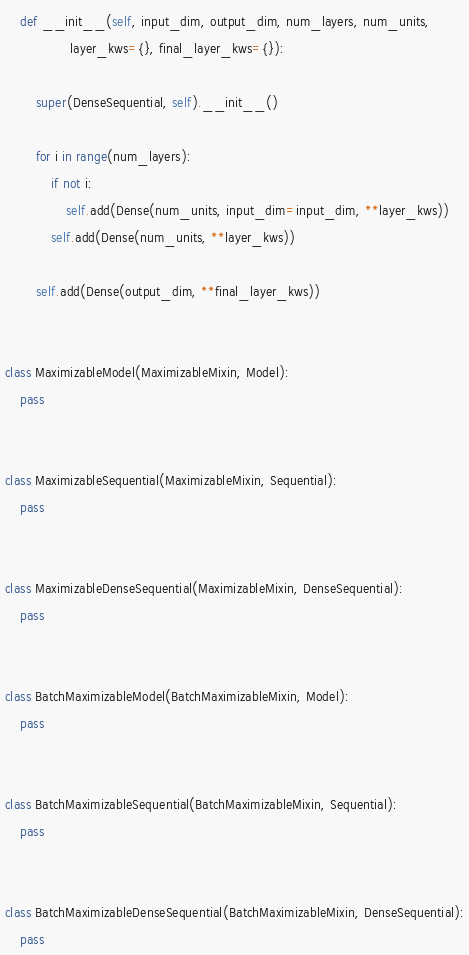Convert code to text. <code><loc_0><loc_0><loc_500><loc_500><_Python_>    def __init__(self, input_dim, output_dim, num_layers, num_units,
                 layer_kws={}, final_layer_kws={}):

        super(DenseSequential, self).__init__()

        for i in range(num_layers):
            if not i:
                self.add(Dense(num_units, input_dim=input_dim, **layer_kws))
            self.add(Dense(num_units, **layer_kws))

        self.add(Dense(output_dim, **final_layer_kws))


class MaximizableModel(MaximizableMixin, Model):
    pass


class MaximizableSequential(MaximizableMixin, Sequential):
    pass


class MaximizableDenseSequential(MaximizableMixin, DenseSequential):
    pass


class BatchMaximizableModel(BatchMaximizableMixin, Model):
    pass


class BatchMaximizableSequential(BatchMaximizableMixin, Sequential):
    pass


class BatchMaximizableDenseSequential(BatchMaximizableMixin, DenseSequential):
    pass
</code> 